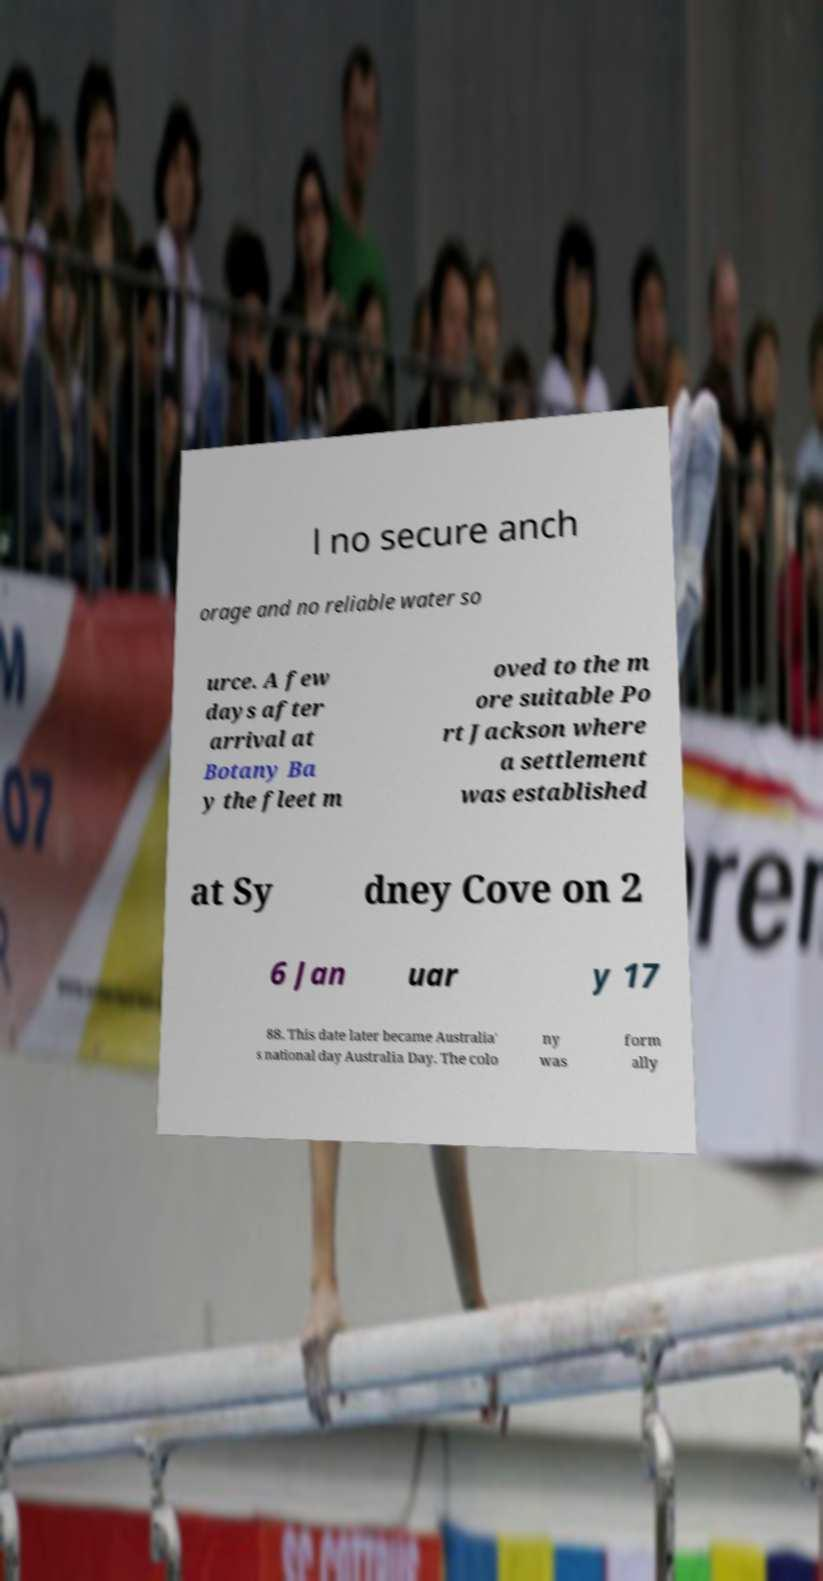Could you assist in decoding the text presented in this image and type it out clearly? l no secure anch orage and no reliable water so urce. A few days after arrival at Botany Ba y the fleet m oved to the m ore suitable Po rt Jackson where a settlement was established at Sy dney Cove on 2 6 Jan uar y 17 88. This date later became Australia' s national day Australia Day. The colo ny was form ally 